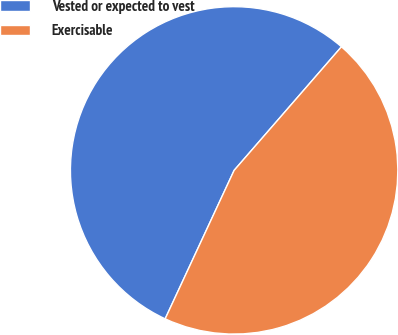Convert chart to OTSL. <chart><loc_0><loc_0><loc_500><loc_500><pie_chart><fcel>Vested or expected to vest<fcel>Exercisable<nl><fcel>54.46%<fcel>45.54%<nl></chart> 